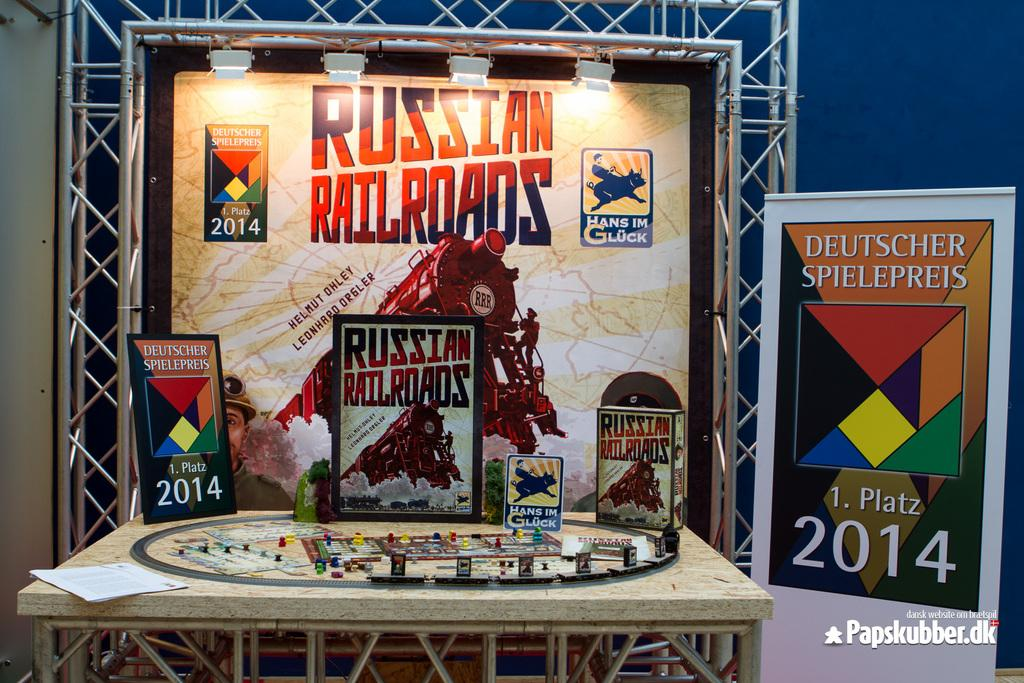<image>
Describe the image concisely. A poster with a train with the title Russian Railroads and a sign on the sign with a 2014 on it 